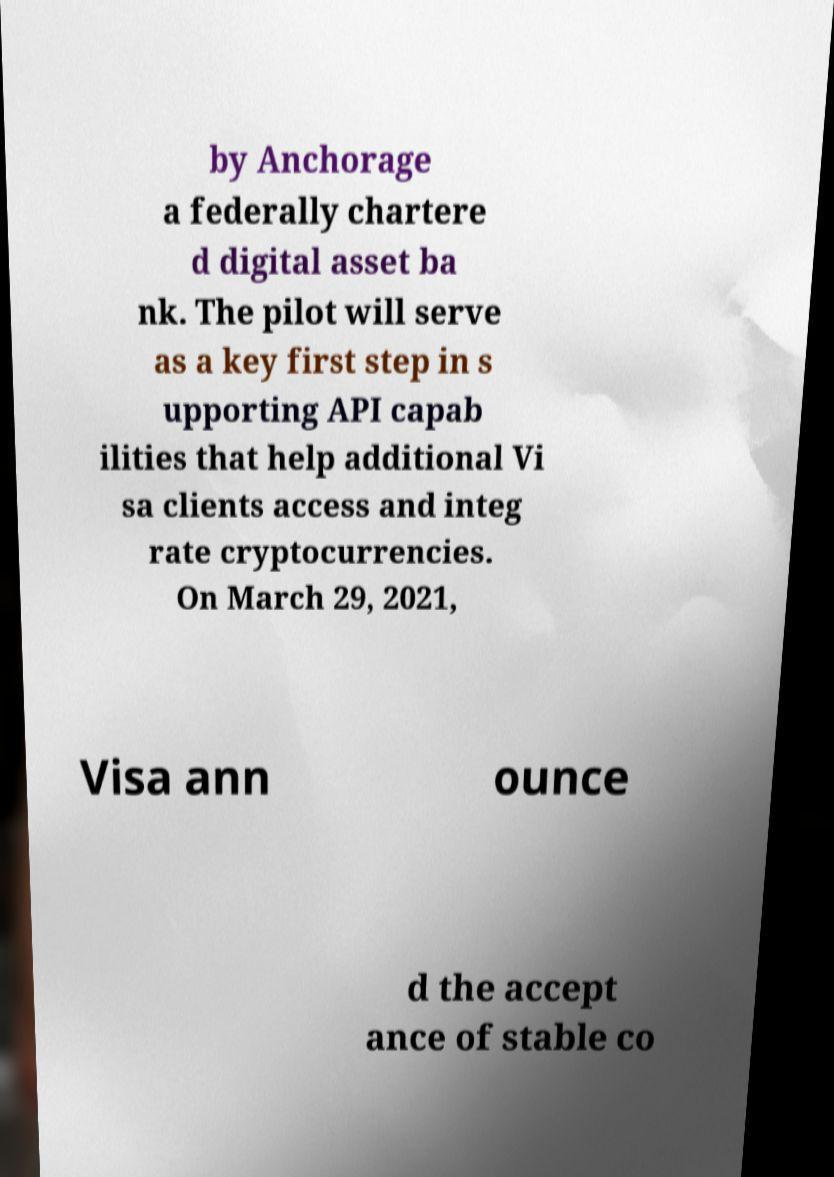Can you read and provide the text displayed in the image?This photo seems to have some interesting text. Can you extract and type it out for me? by Anchorage a federally chartere d digital asset ba nk. The pilot will serve as a key first step in s upporting API capab ilities that help additional Vi sa clients access and integ rate cryptocurrencies. On March 29, 2021, Visa ann ounce d the accept ance of stable co 